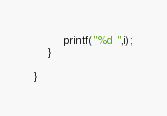Convert code to text. <code><loc_0><loc_0><loc_500><loc_500><_C_>        printf("%d ",i);
    }
    
}
</code> 